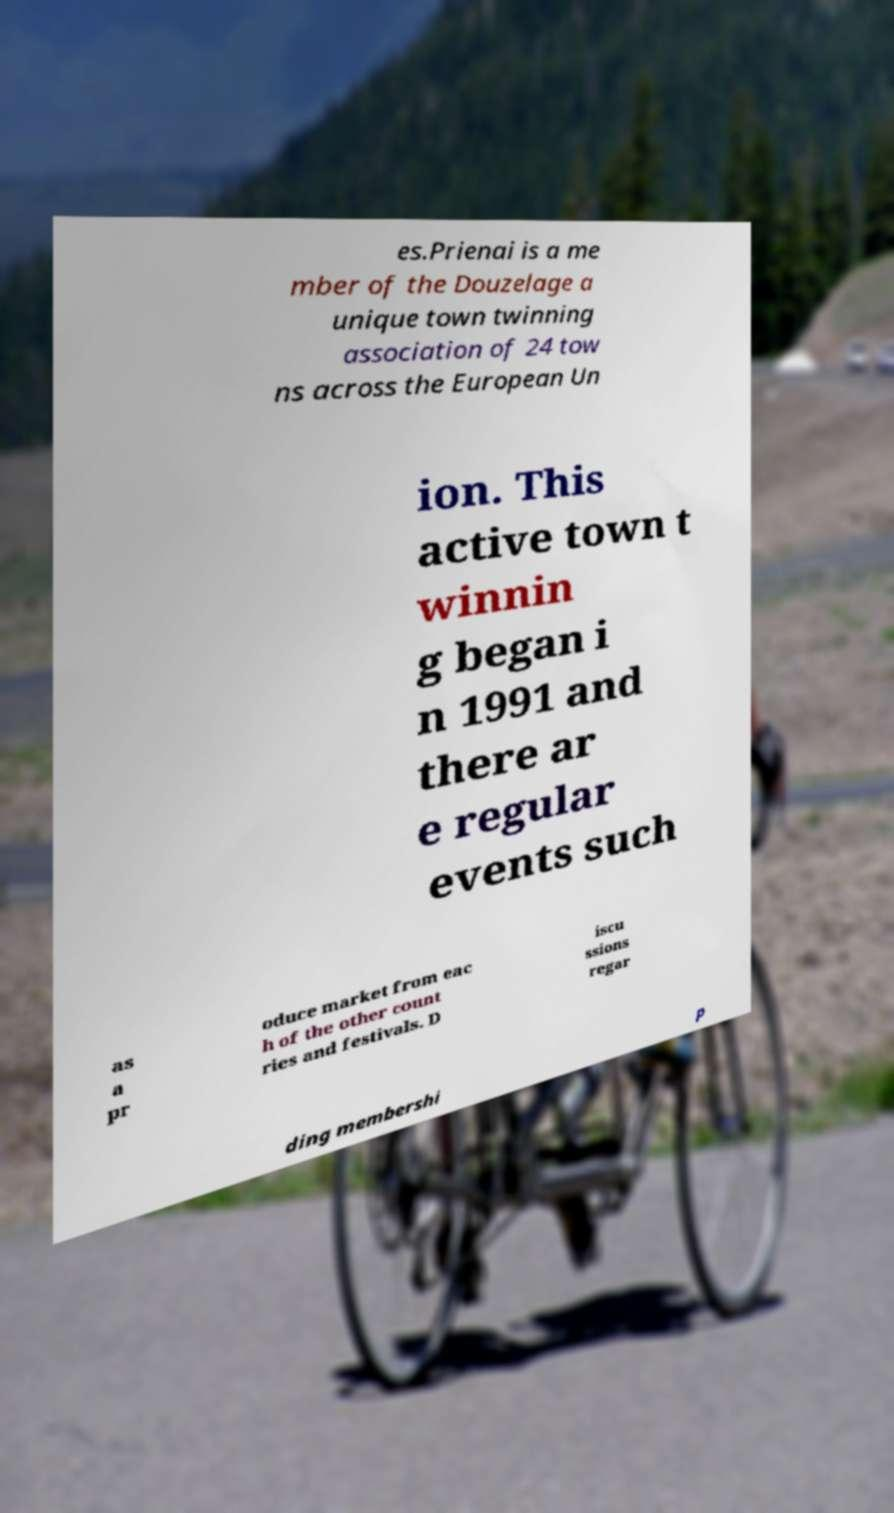Can you accurately transcribe the text from the provided image for me? es.Prienai is a me mber of the Douzelage a unique town twinning association of 24 tow ns across the European Un ion. This active town t winnin g began i n 1991 and there ar e regular events such as a pr oduce market from eac h of the other count ries and festivals. D iscu ssions regar ding membershi p 